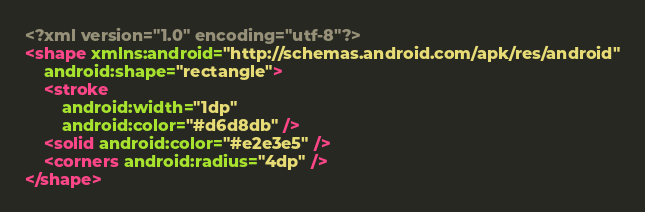<code> <loc_0><loc_0><loc_500><loc_500><_XML_><?xml version="1.0" encoding="utf-8"?>
<shape xmlns:android="http://schemas.android.com/apk/res/android"
    android:shape="rectangle">
    <stroke
        android:width="1dp"
        android:color="#d6d8db" />
    <solid android:color="#e2e3e5" />
    <corners android:radius="4dp" />
</shape></code> 